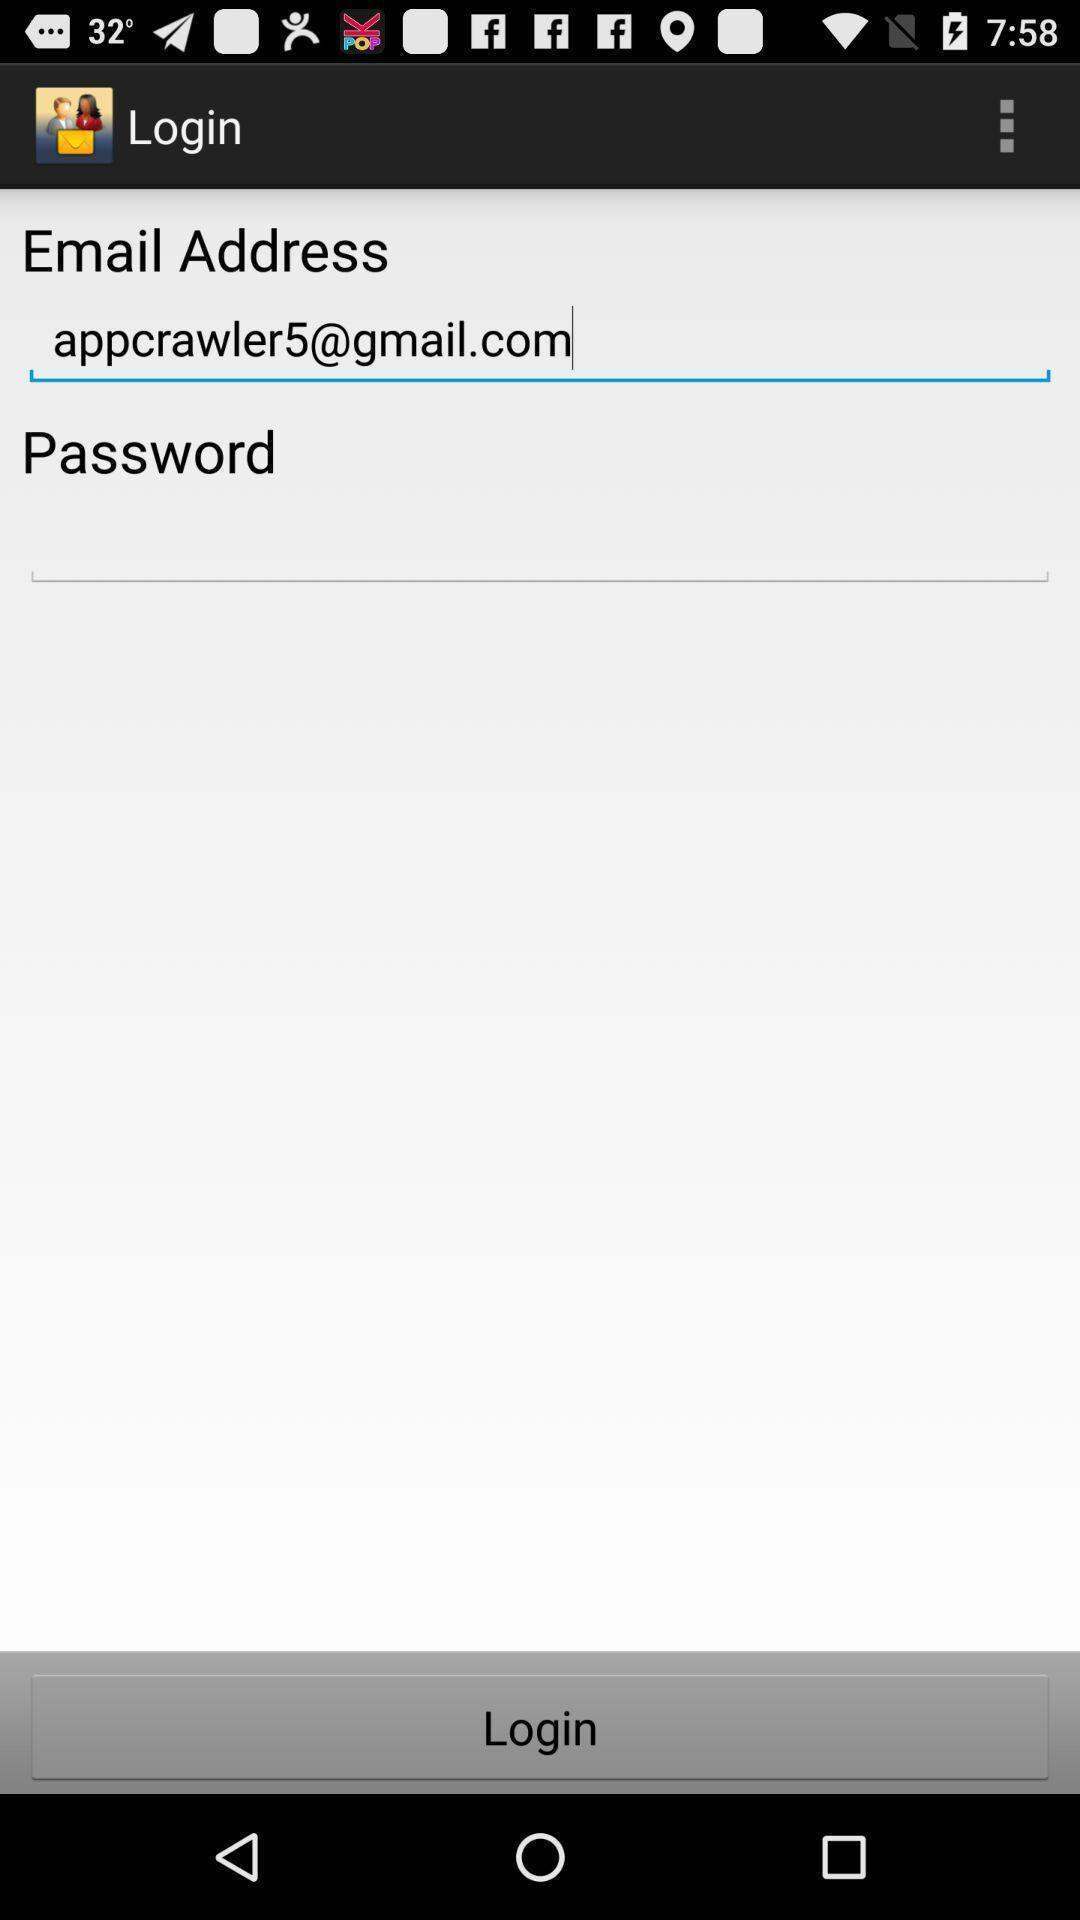Give me a narrative description of this picture. Login page is displaying. 